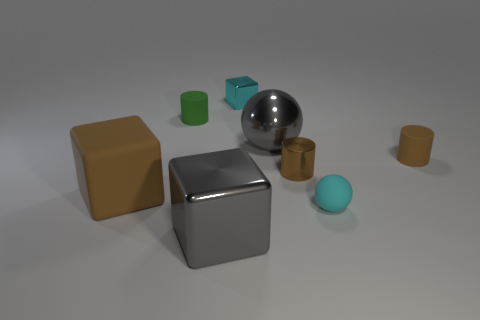How many objects are either small cyan objects that are left of the small metallic cylinder or red rubber blocks?
Make the answer very short. 1. Are there fewer large things than small objects?
Keep it short and to the point. Yes. There is a small brown thing that is made of the same material as the tiny green cylinder; what shape is it?
Ensure brevity in your answer.  Cylinder. There is a small cyan metal block; are there any green matte objects to the right of it?
Offer a very short reply. No. Is the number of tiny green matte cylinders on the left side of the matte block less than the number of green metallic cylinders?
Offer a very short reply. No. What is the material of the big brown thing?
Keep it short and to the point. Rubber. What color is the tiny shiny block?
Your answer should be very brief. Cyan. What color is the matte thing that is both to the left of the cyan ball and right of the large brown block?
Give a very brief answer. Green. Do the tiny block and the big object that is on the left side of the large metallic cube have the same material?
Provide a succinct answer. No. There is a cyan thing that is in front of the metallic block to the right of the big gray metal cube; what is its size?
Provide a short and direct response. Small. 